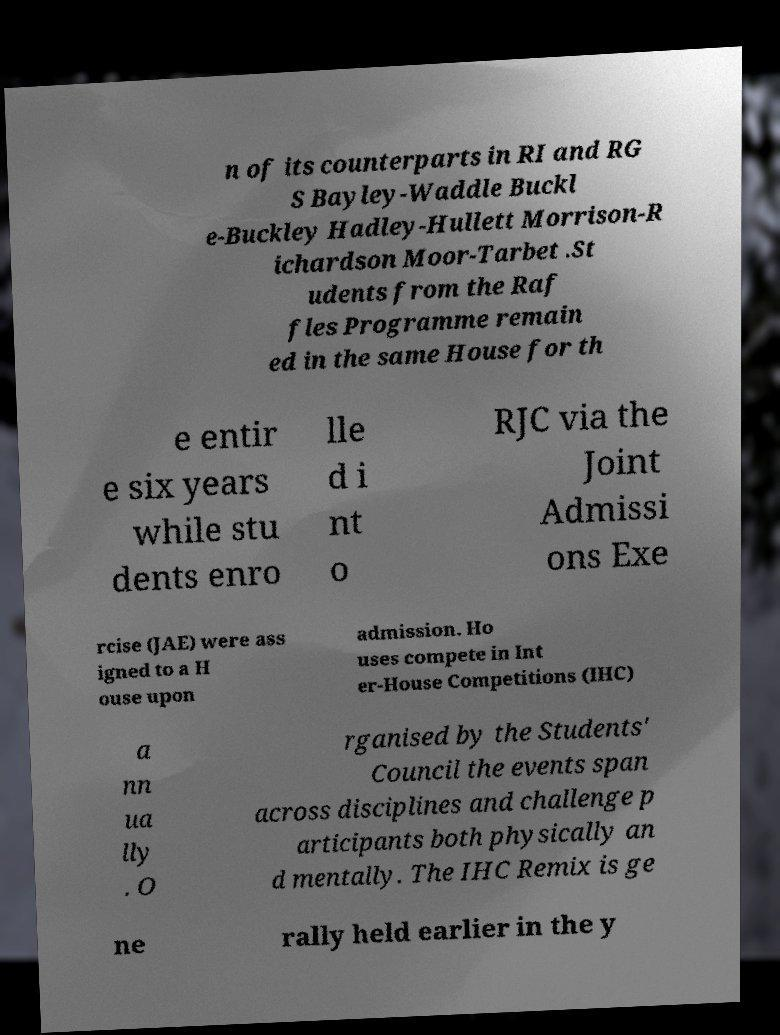Please identify and transcribe the text found in this image. n of its counterparts in RI and RG S Bayley-Waddle Buckl e-Buckley Hadley-Hullett Morrison-R ichardson Moor-Tarbet .St udents from the Raf fles Programme remain ed in the same House for th e entir e six years while stu dents enro lle d i nt o RJC via the Joint Admissi ons Exe rcise (JAE) were ass igned to a H ouse upon admission. Ho uses compete in Int er-House Competitions (IHC) a nn ua lly . O rganised by the Students' Council the events span across disciplines and challenge p articipants both physically an d mentally. The IHC Remix is ge ne rally held earlier in the y 